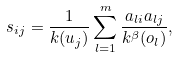<formula> <loc_0><loc_0><loc_500><loc_500>s _ { i j } = \frac { 1 } { k ( u _ { j } ) } \sum ^ { m } _ { l = 1 } \frac { a _ { l i } a _ { l j } } { k ^ { \beta } ( o _ { l } ) } ,</formula> 